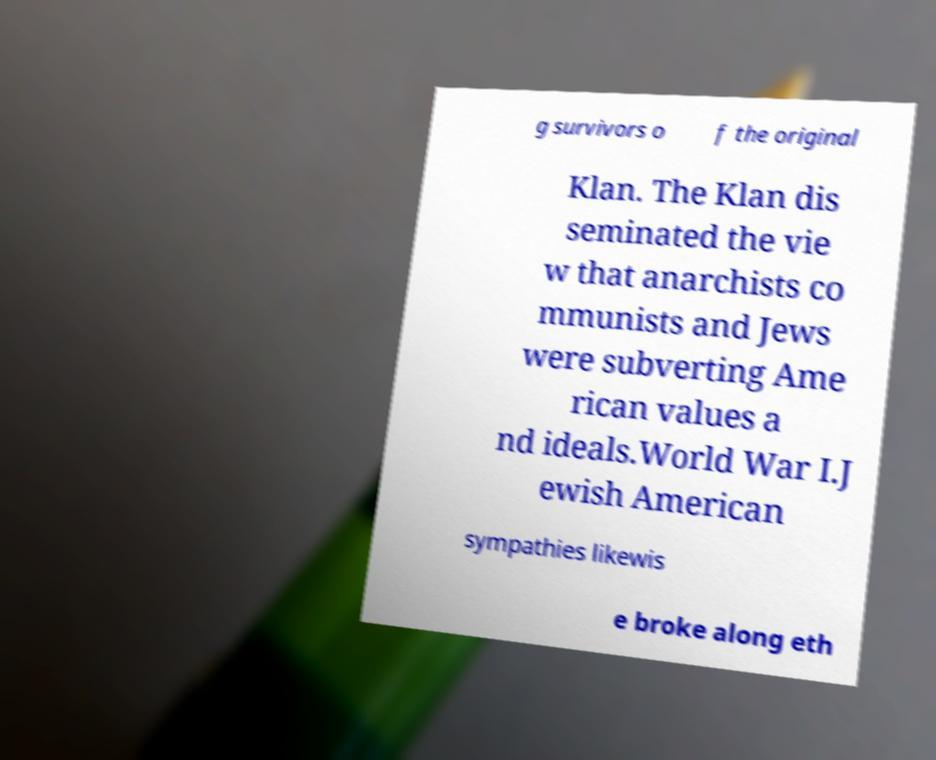Can you accurately transcribe the text from the provided image for me? g survivors o f the original Klan. The Klan dis seminated the vie w that anarchists co mmunists and Jews were subverting Ame rican values a nd ideals.World War I.J ewish American sympathies likewis e broke along eth 